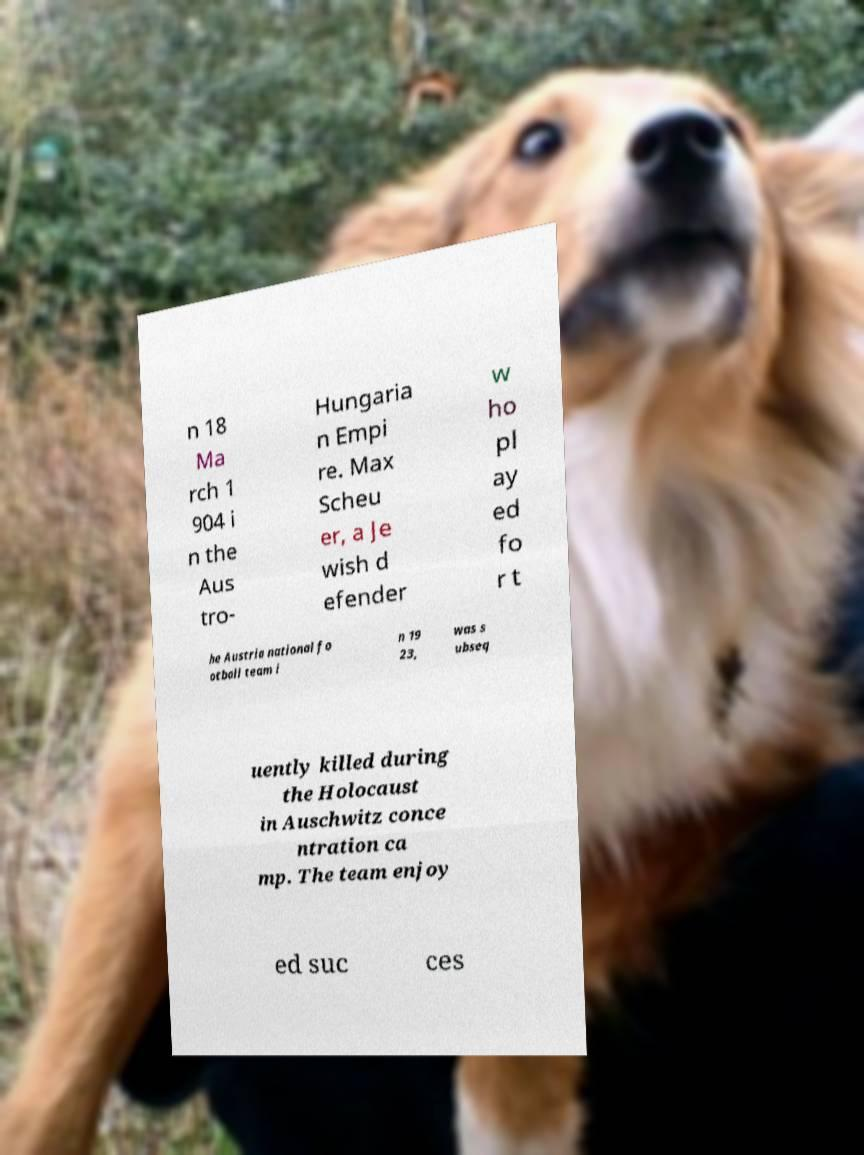What messages or text are displayed in this image? I need them in a readable, typed format. n 18 Ma rch 1 904 i n the Aus tro- Hungaria n Empi re. Max Scheu er, a Je wish d efender w ho pl ay ed fo r t he Austria national fo otball team i n 19 23, was s ubseq uently killed during the Holocaust in Auschwitz conce ntration ca mp. The team enjoy ed suc ces 